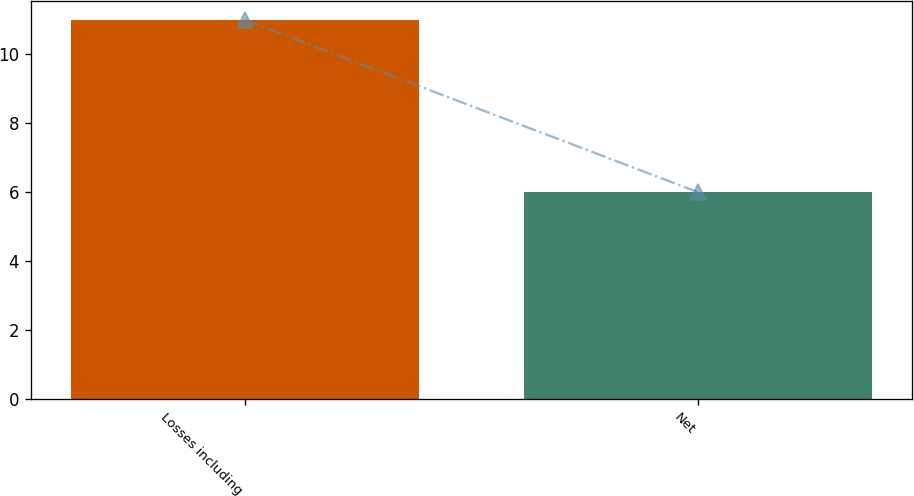Convert chart to OTSL. <chart><loc_0><loc_0><loc_500><loc_500><bar_chart><fcel>Losses including<fcel>Net<nl><fcel>11<fcel>6<nl></chart> 